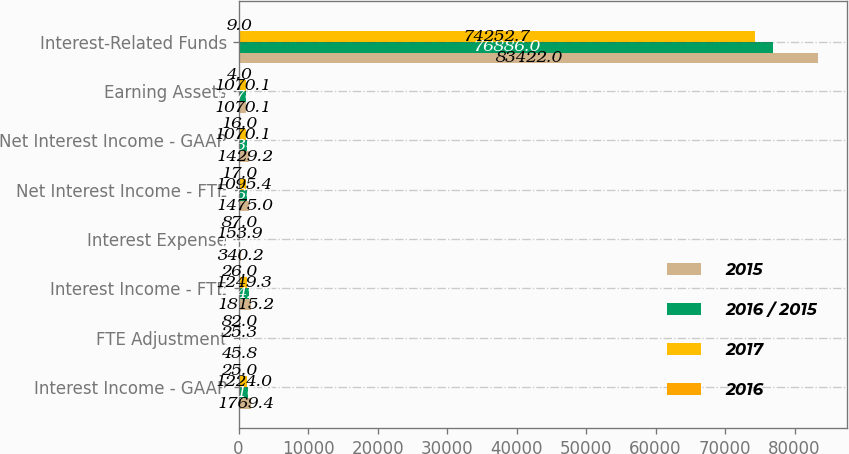Convert chart to OTSL. <chart><loc_0><loc_0><loc_500><loc_500><stacked_bar_chart><ecel><fcel>Interest Income - GAAP<fcel>FTE Adjustment<fcel>Interest Income - FTE<fcel>Interest Expense<fcel>Net Interest Income - FTE<fcel>Net Interest Income - GAAP<fcel>Earning Assets<fcel>Interest-Related Funds<nl><fcel>2015<fcel>1769.4<fcel>45.8<fcel>1815.2<fcel>340.2<fcel>1475<fcel>1429.2<fcel>1070.1<fcel>83422<nl><fcel>2016 / 2015<fcel>1416.9<fcel>25.1<fcel>1442<fcel>182<fcel>1260<fcel>1234.9<fcel>1070.1<fcel>76886<nl><fcel>2017<fcel>1224<fcel>25.3<fcel>1249.3<fcel>153.9<fcel>1095.4<fcel>1070.1<fcel>1070.1<fcel>74252.7<nl><fcel>2016<fcel>25<fcel>82<fcel>26<fcel>87<fcel>17<fcel>16<fcel>4<fcel>9<nl></chart> 